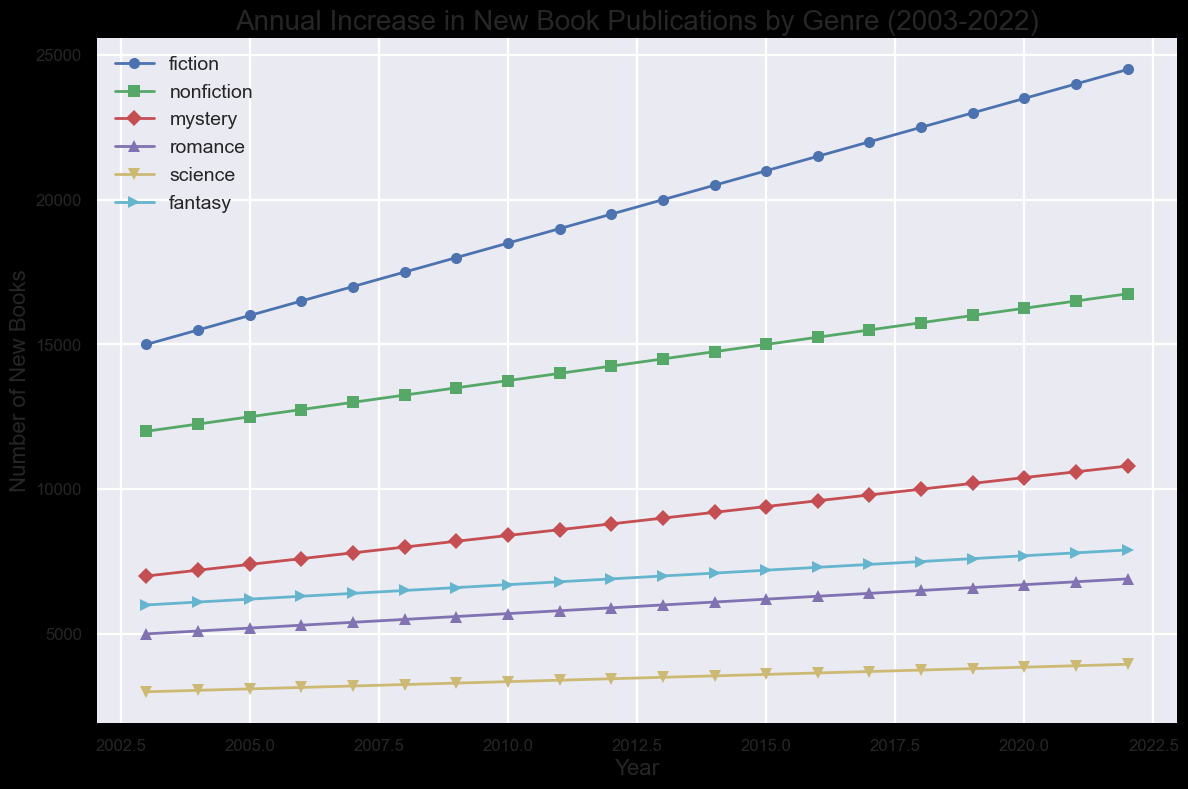What's the trend in fiction book publications from 2003 to 2022? The line for fiction book publications consistently rises from 15,000 in 2003 to 24,500 in 2022, indicating a steady increase.
Answer: Steady increase In which year did mystery book publications reach 10,000? By examining the graph, the mystery genre line reaches 10,000 in 2018.
Answer: 2018 Which genre had the lowest increase in the number of new books from 2003 to 2022? To find the lowest increase, observe the slopes of the lines representing the genres. Science starts at 3,000 and ends at 3,950, an increase of 950 which is the smallest increment compared to other genres.
Answer: Science How did the number of romance book publications change from 2007 to 2015? Check the points for romance at 2007 and 2015: it starts from 5,400 in 2007 and rises to 6,200 in 2015. The number increases by 800 over this period.
Answer: Increased by 800 What is the average number of new nonfiction publications between 2003 and 2022? Sum the number of new nonfiction books each year between 2003 and 2022 and divide by the number of years (20). This average can be calculated by averaging the visible data points on the graph.
Answer: 14,375 Comparing 2010 and 2020, which genre saw the greatest increase in new publications? Look at the difference for each genre between 2010 and 2020. Fiction increases from 18,500 to 23,500 (5,000), Nonfiction from 13,750 to 16,250 (2,500), Mystery from 8,400 to 10,400 (2,000), Romance from 5,700 to 6,700 (1,000), Science from 3,350 to 3,850 (500), and Fantasy from 6,700 to 7,700 (1,000). Fiction has the greatest increase of 5,000.
Answer: Fiction Which genre consistently had more new books published than romance from 2003 to 2022? The lines for Fiction, Nonfiction, and Mystery are consistently above Romance throughout the years 2003-2022.
Answer: Fiction, Nonfiction, Mystery In which year did Fantasy surpass 7,000 new books for the first time? By locating the point where the Fantasy line first crosses the 7,000 mark, we can see it happens in 2013.
Answer: 2013 How much did the number of new science publications change from 2015 to 2022? Look at the values for Science in 2015 (3,600) and 2022 (3,950), the difference is 350.
Answer: Increased by 350 Between 2003 and 2022, which genres had more than tripled their initial number of publications? Check for genres where the final value in 2022 is more than three times their initial value in 2003: none of the genres fit this criterion by inspection.
Answer: None 